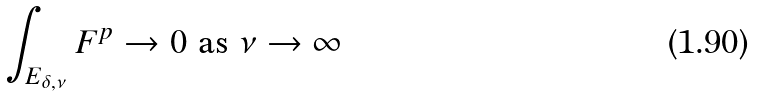<formula> <loc_0><loc_0><loc_500><loc_500>\int _ { E _ { \delta , \nu } } F ^ { p } \to 0 \text { as } \nu \to \infty</formula> 